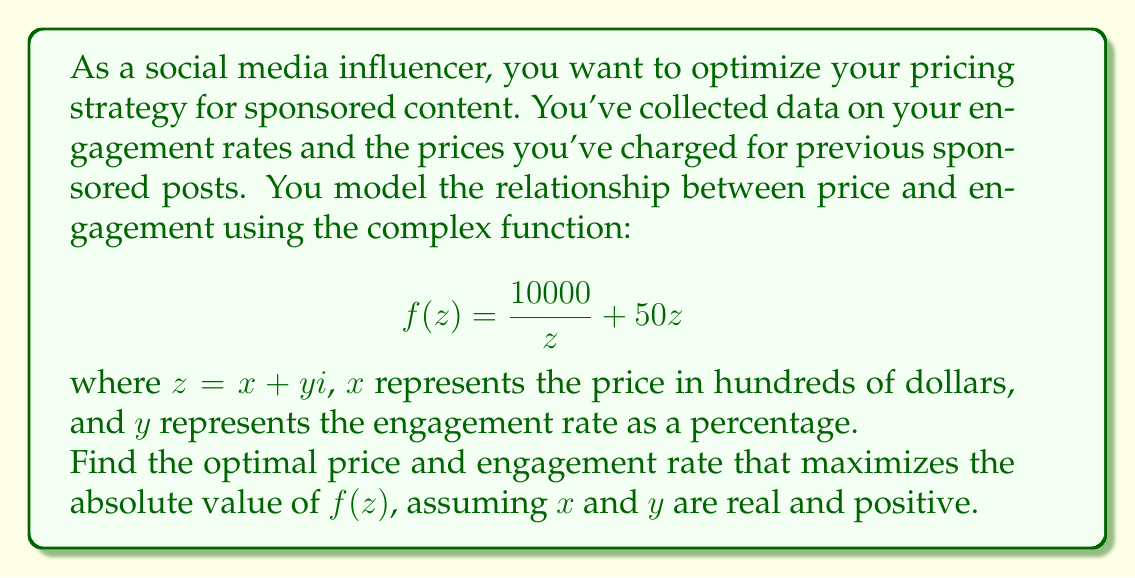Help me with this question. To find the optimal price and engagement rate, we need to maximize the absolute value of $f(z)$. Let's approach this step-by-step:

1) First, we calculate the absolute value of $f(z)$:

   $$|f(z)| = \left|\frac{10000}{z} + 50z\right|$$

2) In the complex plane, this represents the distance from the origin to the point $f(z)$. To maximize this, we can use the AM-GM inequality, which states that the arithmetic mean of two positive real numbers is always greater than or equal to the geometric mean of the same two numbers.

3) Let $a = \left|\frac{10000}{z}\right|$ and $b = |50z|$. Then:

   $$|f(z)| = |a + b| \leq |a| + |b|$$

4) The equality holds when $a = b$, which gives us the condition for maximization:

   $$\left|\frac{10000}{z}\right| = |50z|$$

5) Simplifying:

   $$10000 = 50|z|^2$$
   $$|z|^2 = 200$$
   $$|z| = \sqrt{200} = 10\sqrt{2}$$

6) Since $z = x + yi$ and both $x$ and $y$ are real and positive, we can conclude:

   $$x = y = \frac{10\sqrt{2}}{2} = 5\sqrt{2}$$

7) Converting back to our original units:
   - Optimal price: $5\sqrt{2} \times 100 \approx 707.11$ dollars
   - Optimal engagement rate: $5\sqrt{2}\% \approx 7.07\%$

8) The maximum value of $|f(z)|$ occurs at this point:

   $$|f(z)| = \left|\frac{10000}{10\sqrt{2}} + 50(10\sqrt{2})\right| = 1000\sqrt{2} \approx 1414.21$$
Answer: The optimal pricing strategy is to charge approximately $707.11 for sponsored content at an engagement rate of about 7.07%. This maximizes the value of the complex function to approximately 1414.21. 